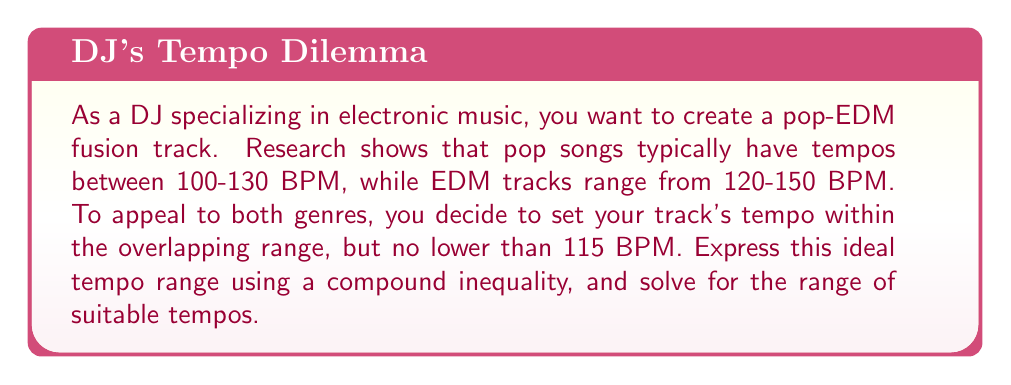What is the answer to this math problem? Let's approach this step-by-step:

1) First, let's define our variable:
   Let $x$ = the tempo of the track in BPM

2) Now, let's break down the constraints:
   - Pop range: $100 \leq x \leq 130$
   - EDM range: $120 \leq x \leq 150$
   - Additional constraint: $x \geq 115$

3) To find the overlapping range, we need to combine these inequalities:
   $\max(100, 120, 115) \leq x \leq \min(130, 150)$

4) Simplifying:
   $120 \leq x \leq 130$

5) We can express this as a compound inequality:
   $120 \leq x \leq 130$

6) To solve for the range, we simply need to state the lower and upper bounds:
   The ideal tempo range is from 120 BPM to 130 BPM.

Therefore, the compound inequality representing the ideal tempo range is $120 \leq x \leq 130$, where $x$ is the tempo in BPM.
Answer: $120 \leq x \leq 130$, where $x$ is the tempo in BPM 